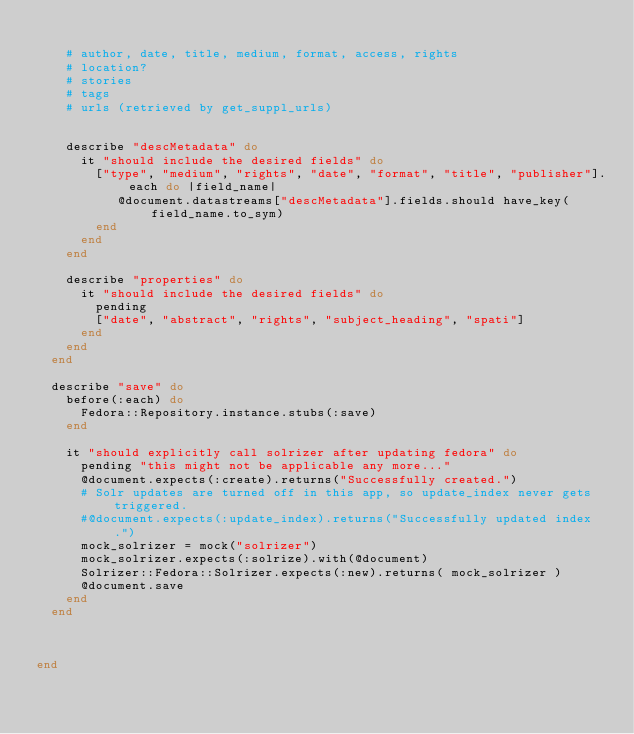Convert code to text. <code><loc_0><loc_0><loc_500><loc_500><_Ruby_>    
    # author, date, title, medium, format, access, rights
    # location?
    # stories
    # tags
    # urls (retrieved by get_suppl_urls)
    
    
    describe "descMetadata" do
      it "should include the desired fields" do
        ["type", "medium", "rights", "date", "format", "title", "publisher"].each do |field_name|
           @document.datastreams["descMetadata"].fields.should have_key(field_name.to_sym)
        end
      end
    end
    
    describe "properties" do
      it "should include the desired fields" do
        pending
        ["date", "abstract", "rights", "subject_heading", "spati"]
      end
    end
  end
  
  describe "save" do
    before(:each) do
      Fedora::Repository.instance.stubs(:save)
    end
    
    it "should explicitly call solrizer after updating fedora" do
      pending "this might not be applicable any more..."
      @document.expects(:create).returns("Successfully created.")
      # Solr updates are turned off in this app, so update_index never gets triggered.
      #@document.expects(:update_index).returns("Successfully updated index.")
      mock_solrizer = mock("solrizer")
      mock_solrizer.expects(:solrize).with(@document)
      Solrizer::Fedora::Solrizer.expects(:new).returns( mock_solrizer )
      @document.save
    end
  end

  
  
end</code> 